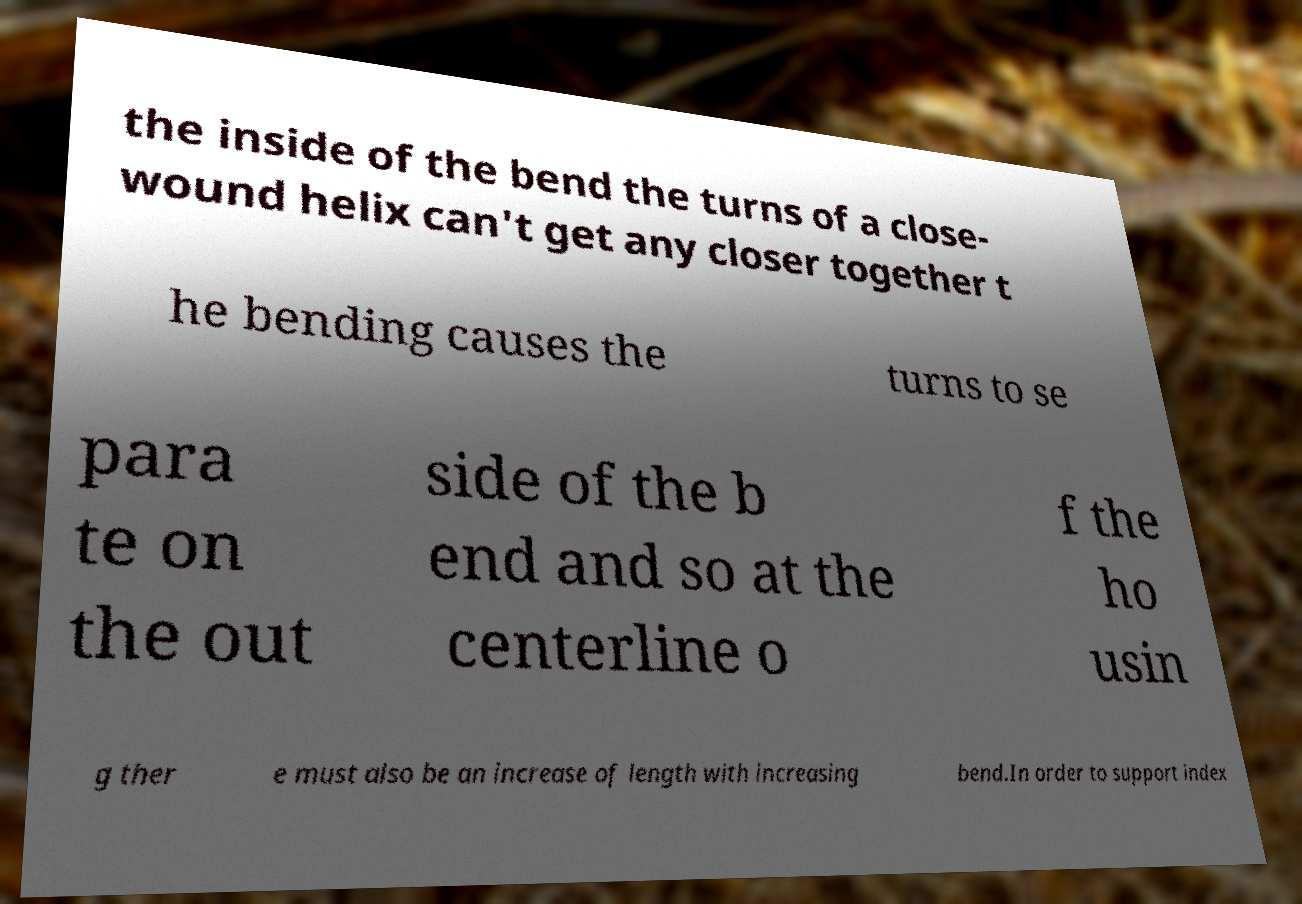Could you assist in decoding the text presented in this image and type it out clearly? the inside of the bend the turns of a close- wound helix can't get any closer together t he bending causes the turns to se para te on the out side of the b end and so at the centerline o f the ho usin g ther e must also be an increase of length with increasing bend.In order to support index 